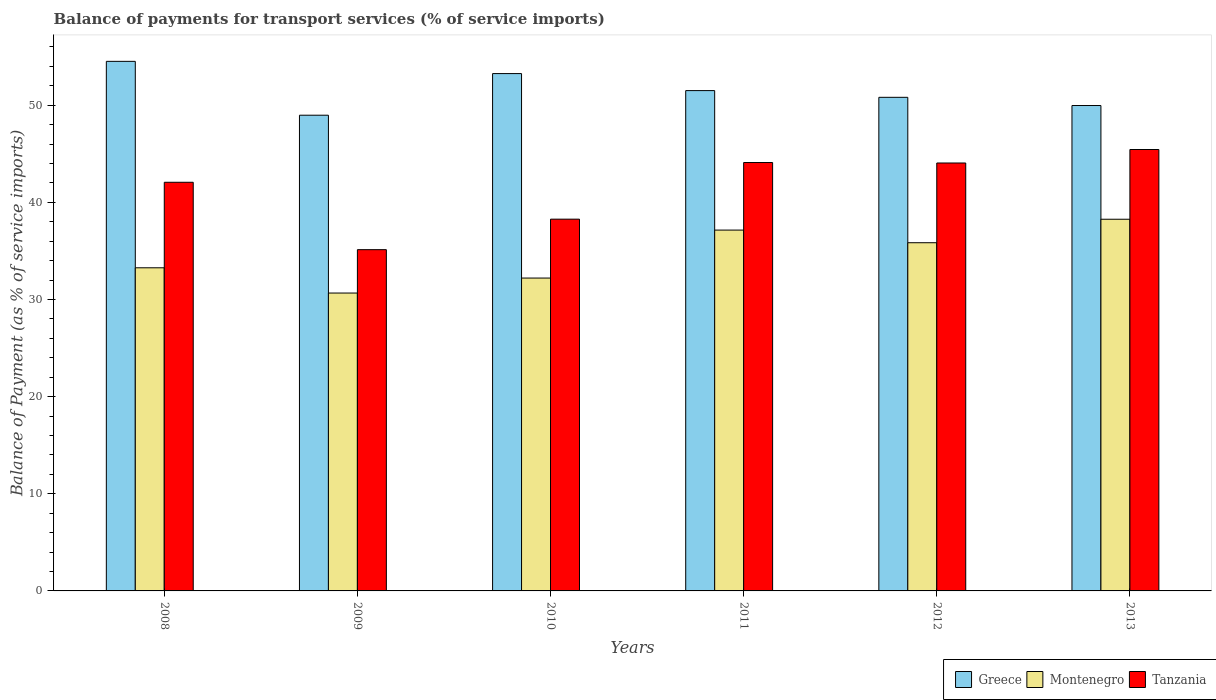How many different coloured bars are there?
Your response must be concise. 3. Are the number of bars per tick equal to the number of legend labels?
Provide a succinct answer. Yes. How many bars are there on the 4th tick from the left?
Offer a terse response. 3. What is the label of the 6th group of bars from the left?
Provide a succinct answer. 2013. What is the balance of payments for transport services in Montenegro in 2011?
Give a very brief answer. 37.14. Across all years, what is the maximum balance of payments for transport services in Montenegro?
Your response must be concise. 38.26. Across all years, what is the minimum balance of payments for transport services in Greece?
Provide a succinct answer. 48.97. In which year was the balance of payments for transport services in Montenegro maximum?
Give a very brief answer. 2013. What is the total balance of payments for transport services in Greece in the graph?
Keep it short and to the point. 309. What is the difference between the balance of payments for transport services in Tanzania in 2009 and that in 2013?
Your answer should be compact. -10.31. What is the difference between the balance of payments for transport services in Greece in 2008 and the balance of payments for transport services in Montenegro in 2010?
Your answer should be compact. 22.31. What is the average balance of payments for transport services in Tanzania per year?
Keep it short and to the point. 41.51. In the year 2011, what is the difference between the balance of payments for transport services in Montenegro and balance of payments for transport services in Tanzania?
Provide a short and direct response. -6.96. What is the ratio of the balance of payments for transport services in Greece in 2011 to that in 2012?
Keep it short and to the point. 1.01. Is the balance of payments for transport services in Montenegro in 2008 less than that in 2013?
Your answer should be very brief. Yes. What is the difference between the highest and the second highest balance of payments for transport services in Greece?
Make the answer very short. 1.26. What is the difference between the highest and the lowest balance of payments for transport services in Tanzania?
Your answer should be compact. 10.31. Is the sum of the balance of payments for transport services in Tanzania in 2008 and 2010 greater than the maximum balance of payments for transport services in Greece across all years?
Offer a terse response. Yes. What does the 2nd bar from the right in 2010 represents?
Keep it short and to the point. Montenegro. Is it the case that in every year, the sum of the balance of payments for transport services in Tanzania and balance of payments for transport services in Greece is greater than the balance of payments for transport services in Montenegro?
Your answer should be compact. Yes. Are all the bars in the graph horizontal?
Provide a succinct answer. No. Are the values on the major ticks of Y-axis written in scientific E-notation?
Ensure brevity in your answer.  No. Does the graph contain any zero values?
Your answer should be very brief. No. Where does the legend appear in the graph?
Offer a terse response. Bottom right. How are the legend labels stacked?
Ensure brevity in your answer.  Horizontal. What is the title of the graph?
Provide a succinct answer. Balance of payments for transport services (% of service imports). What is the label or title of the Y-axis?
Your answer should be compact. Balance of Payment (as % of service imports). What is the Balance of Payment (as % of service imports) of Greece in 2008?
Ensure brevity in your answer.  54.51. What is the Balance of Payment (as % of service imports) of Montenegro in 2008?
Ensure brevity in your answer.  33.26. What is the Balance of Payment (as % of service imports) in Tanzania in 2008?
Offer a terse response. 42.06. What is the Balance of Payment (as % of service imports) in Greece in 2009?
Offer a terse response. 48.97. What is the Balance of Payment (as % of service imports) in Montenegro in 2009?
Give a very brief answer. 30.66. What is the Balance of Payment (as % of service imports) of Tanzania in 2009?
Make the answer very short. 35.13. What is the Balance of Payment (as % of service imports) of Greece in 2010?
Give a very brief answer. 53.25. What is the Balance of Payment (as % of service imports) in Montenegro in 2010?
Your answer should be compact. 32.2. What is the Balance of Payment (as % of service imports) in Tanzania in 2010?
Make the answer very short. 38.27. What is the Balance of Payment (as % of service imports) of Greece in 2011?
Ensure brevity in your answer.  51.5. What is the Balance of Payment (as % of service imports) in Montenegro in 2011?
Offer a terse response. 37.14. What is the Balance of Payment (as % of service imports) of Tanzania in 2011?
Offer a terse response. 44.1. What is the Balance of Payment (as % of service imports) of Greece in 2012?
Provide a succinct answer. 50.81. What is the Balance of Payment (as % of service imports) of Montenegro in 2012?
Ensure brevity in your answer.  35.84. What is the Balance of Payment (as % of service imports) of Tanzania in 2012?
Offer a terse response. 44.05. What is the Balance of Payment (as % of service imports) of Greece in 2013?
Your answer should be compact. 49.96. What is the Balance of Payment (as % of service imports) in Montenegro in 2013?
Offer a very short reply. 38.26. What is the Balance of Payment (as % of service imports) in Tanzania in 2013?
Offer a very short reply. 45.44. Across all years, what is the maximum Balance of Payment (as % of service imports) of Greece?
Make the answer very short. 54.51. Across all years, what is the maximum Balance of Payment (as % of service imports) in Montenegro?
Your answer should be very brief. 38.26. Across all years, what is the maximum Balance of Payment (as % of service imports) of Tanzania?
Your answer should be very brief. 45.44. Across all years, what is the minimum Balance of Payment (as % of service imports) in Greece?
Your answer should be very brief. 48.97. Across all years, what is the minimum Balance of Payment (as % of service imports) in Montenegro?
Offer a terse response. 30.66. Across all years, what is the minimum Balance of Payment (as % of service imports) in Tanzania?
Your response must be concise. 35.13. What is the total Balance of Payment (as % of service imports) of Greece in the graph?
Make the answer very short. 309. What is the total Balance of Payment (as % of service imports) in Montenegro in the graph?
Give a very brief answer. 207.37. What is the total Balance of Payment (as % of service imports) in Tanzania in the graph?
Your answer should be compact. 249.04. What is the difference between the Balance of Payment (as % of service imports) in Greece in 2008 and that in 2009?
Offer a terse response. 5.54. What is the difference between the Balance of Payment (as % of service imports) of Montenegro in 2008 and that in 2009?
Provide a short and direct response. 2.6. What is the difference between the Balance of Payment (as % of service imports) in Tanzania in 2008 and that in 2009?
Ensure brevity in your answer.  6.94. What is the difference between the Balance of Payment (as % of service imports) in Greece in 2008 and that in 2010?
Your response must be concise. 1.26. What is the difference between the Balance of Payment (as % of service imports) of Montenegro in 2008 and that in 2010?
Provide a succinct answer. 1.06. What is the difference between the Balance of Payment (as % of service imports) of Tanzania in 2008 and that in 2010?
Provide a short and direct response. 3.8. What is the difference between the Balance of Payment (as % of service imports) in Greece in 2008 and that in 2011?
Your answer should be compact. 3.01. What is the difference between the Balance of Payment (as % of service imports) in Montenegro in 2008 and that in 2011?
Keep it short and to the point. -3.88. What is the difference between the Balance of Payment (as % of service imports) of Tanzania in 2008 and that in 2011?
Give a very brief answer. -2.03. What is the difference between the Balance of Payment (as % of service imports) in Greece in 2008 and that in 2012?
Provide a short and direct response. 3.7. What is the difference between the Balance of Payment (as % of service imports) in Montenegro in 2008 and that in 2012?
Your response must be concise. -2.58. What is the difference between the Balance of Payment (as % of service imports) of Tanzania in 2008 and that in 2012?
Offer a terse response. -1.98. What is the difference between the Balance of Payment (as % of service imports) in Greece in 2008 and that in 2013?
Provide a short and direct response. 4.55. What is the difference between the Balance of Payment (as % of service imports) in Montenegro in 2008 and that in 2013?
Offer a very short reply. -5. What is the difference between the Balance of Payment (as % of service imports) of Tanzania in 2008 and that in 2013?
Offer a very short reply. -3.37. What is the difference between the Balance of Payment (as % of service imports) of Greece in 2009 and that in 2010?
Provide a short and direct response. -4.28. What is the difference between the Balance of Payment (as % of service imports) of Montenegro in 2009 and that in 2010?
Your answer should be very brief. -1.54. What is the difference between the Balance of Payment (as % of service imports) of Tanzania in 2009 and that in 2010?
Provide a short and direct response. -3.14. What is the difference between the Balance of Payment (as % of service imports) of Greece in 2009 and that in 2011?
Provide a succinct answer. -2.53. What is the difference between the Balance of Payment (as % of service imports) in Montenegro in 2009 and that in 2011?
Offer a terse response. -6.48. What is the difference between the Balance of Payment (as % of service imports) of Tanzania in 2009 and that in 2011?
Provide a short and direct response. -8.97. What is the difference between the Balance of Payment (as % of service imports) in Greece in 2009 and that in 2012?
Offer a very short reply. -1.84. What is the difference between the Balance of Payment (as % of service imports) of Montenegro in 2009 and that in 2012?
Ensure brevity in your answer.  -5.18. What is the difference between the Balance of Payment (as % of service imports) of Tanzania in 2009 and that in 2012?
Your answer should be very brief. -8.92. What is the difference between the Balance of Payment (as % of service imports) of Greece in 2009 and that in 2013?
Your response must be concise. -1. What is the difference between the Balance of Payment (as % of service imports) in Montenegro in 2009 and that in 2013?
Ensure brevity in your answer.  -7.6. What is the difference between the Balance of Payment (as % of service imports) of Tanzania in 2009 and that in 2013?
Provide a succinct answer. -10.31. What is the difference between the Balance of Payment (as % of service imports) of Greece in 2010 and that in 2011?
Give a very brief answer. 1.75. What is the difference between the Balance of Payment (as % of service imports) in Montenegro in 2010 and that in 2011?
Your answer should be very brief. -4.94. What is the difference between the Balance of Payment (as % of service imports) of Tanzania in 2010 and that in 2011?
Give a very brief answer. -5.83. What is the difference between the Balance of Payment (as % of service imports) in Greece in 2010 and that in 2012?
Offer a very short reply. 2.44. What is the difference between the Balance of Payment (as % of service imports) of Montenegro in 2010 and that in 2012?
Provide a short and direct response. -3.64. What is the difference between the Balance of Payment (as % of service imports) in Tanzania in 2010 and that in 2012?
Offer a very short reply. -5.78. What is the difference between the Balance of Payment (as % of service imports) in Greece in 2010 and that in 2013?
Keep it short and to the point. 3.29. What is the difference between the Balance of Payment (as % of service imports) of Montenegro in 2010 and that in 2013?
Offer a terse response. -6.06. What is the difference between the Balance of Payment (as % of service imports) in Tanzania in 2010 and that in 2013?
Ensure brevity in your answer.  -7.17. What is the difference between the Balance of Payment (as % of service imports) in Greece in 2011 and that in 2012?
Provide a short and direct response. 0.69. What is the difference between the Balance of Payment (as % of service imports) of Montenegro in 2011 and that in 2012?
Offer a very short reply. 1.3. What is the difference between the Balance of Payment (as % of service imports) of Tanzania in 2011 and that in 2012?
Your answer should be compact. 0.05. What is the difference between the Balance of Payment (as % of service imports) in Greece in 2011 and that in 2013?
Offer a terse response. 1.54. What is the difference between the Balance of Payment (as % of service imports) in Montenegro in 2011 and that in 2013?
Offer a terse response. -1.12. What is the difference between the Balance of Payment (as % of service imports) of Tanzania in 2011 and that in 2013?
Your answer should be very brief. -1.34. What is the difference between the Balance of Payment (as % of service imports) of Greece in 2012 and that in 2013?
Offer a terse response. 0.85. What is the difference between the Balance of Payment (as % of service imports) in Montenegro in 2012 and that in 2013?
Provide a short and direct response. -2.42. What is the difference between the Balance of Payment (as % of service imports) in Tanzania in 2012 and that in 2013?
Keep it short and to the point. -1.39. What is the difference between the Balance of Payment (as % of service imports) in Greece in 2008 and the Balance of Payment (as % of service imports) in Montenegro in 2009?
Your answer should be very brief. 23.85. What is the difference between the Balance of Payment (as % of service imports) of Greece in 2008 and the Balance of Payment (as % of service imports) of Tanzania in 2009?
Provide a succinct answer. 19.38. What is the difference between the Balance of Payment (as % of service imports) in Montenegro in 2008 and the Balance of Payment (as % of service imports) in Tanzania in 2009?
Keep it short and to the point. -1.86. What is the difference between the Balance of Payment (as % of service imports) of Greece in 2008 and the Balance of Payment (as % of service imports) of Montenegro in 2010?
Provide a succinct answer. 22.31. What is the difference between the Balance of Payment (as % of service imports) in Greece in 2008 and the Balance of Payment (as % of service imports) in Tanzania in 2010?
Your answer should be compact. 16.24. What is the difference between the Balance of Payment (as % of service imports) in Montenegro in 2008 and the Balance of Payment (as % of service imports) in Tanzania in 2010?
Provide a succinct answer. -5. What is the difference between the Balance of Payment (as % of service imports) of Greece in 2008 and the Balance of Payment (as % of service imports) of Montenegro in 2011?
Ensure brevity in your answer.  17.37. What is the difference between the Balance of Payment (as % of service imports) in Greece in 2008 and the Balance of Payment (as % of service imports) in Tanzania in 2011?
Make the answer very short. 10.41. What is the difference between the Balance of Payment (as % of service imports) of Montenegro in 2008 and the Balance of Payment (as % of service imports) of Tanzania in 2011?
Provide a succinct answer. -10.84. What is the difference between the Balance of Payment (as % of service imports) in Greece in 2008 and the Balance of Payment (as % of service imports) in Montenegro in 2012?
Provide a succinct answer. 18.67. What is the difference between the Balance of Payment (as % of service imports) in Greece in 2008 and the Balance of Payment (as % of service imports) in Tanzania in 2012?
Provide a short and direct response. 10.46. What is the difference between the Balance of Payment (as % of service imports) in Montenegro in 2008 and the Balance of Payment (as % of service imports) in Tanzania in 2012?
Offer a very short reply. -10.79. What is the difference between the Balance of Payment (as % of service imports) in Greece in 2008 and the Balance of Payment (as % of service imports) in Montenegro in 2013?
Provide a succinct answer. 16.25. What is the difference between the Balance of Payment (as % of service imports) of Greece in 2008 and the Balance of Payment (as % of service imports) of Tanzania in 2013?
Give a very brief answer. 9.07. What is the difference between the Balance of Payment (as % of service imports) of Montenegro in 2008 and the Balance of Payment (as % of service imports) of Tanzania in 2013?
Keep it short and to the point. -12.18. What is the difference between the Balance of Payment (as % of service imports) of Greece in 2009 and the Balance of Payment (as % of service imports) of Montenegro in 2010?
Your answer should be very brief. 16.76. What is the difference between the Balance of Payment (as % of service imports) in Montenegro in 2009 and the Balance of Payment (as % of service imports) in Tanzania in 2010?
Make the answer very short. -7.6. What is the difference between the Balance of Payment (as % of service imports) of Greece in 2009 and the Balance of Payment (as % of service imports) of Montenegro in 2011?
Provide a short and direct response. 11.82. What is the difference between the Balance of Payment (as % of service imports) of Greece in 2009 and the Balance of Payment (as % of service imports) of Tanzania in 2011?
Make the answer very short. 4.87. What is the difference between the Balance of Payment (as % of service imports) in Montenegro in 2009 and the Balance of Payment (as % of service imports) in Tanzania in 2011?
Provide a succinct answer. -13.44. What is the difference between the Balance of Payment (as % of service imports) of Greece in 2009 and the Balance of Payment (as % of service imports) of Montenegro in 2012?
Your answer should be very brief. 13.13. What is the difference between the Balance of Payment (as % of service imports) of Greece in 2009 and the Balance of Payment (as % of service imports) of Tanzania in 2012?
Give a very brief answer. 4.92. What is the difference between the Balance of Payment (as % of service imports) of Montenegro in 2009 and the Balance of Payment (as % of service imports) of Tanzania in 2012?
Ensure brevity in your answer.  -13.39. What is the difference between the Balance of Payment (as % of service imports) in Greece in 2009 and the Balance of Payment (as % of service imports) in Montenegro in 2013?
Make the answer very short. 10.71. What is the difference between the Balance of Payment (as % of service imports) in Greece in 2009 and the Balance of Payment (as % of service imports) in Tanzania in 2013?
Your answer should be compact. 3.53. What is the difference between the Balance of Payment (as % of service imports) in Montenegro in 2009 and the Balance of Payment (as % of service imports) in Tanzania in 2013?
Offer a very short reply. -14.78. What is the difference between the Balance of Payment (as % of service imports) in Greece in 2010 and the Balance of Payment (as % of service imports) in Montenegro in 2011?
Make the answer very short. 16.11. What is the difference between the Balance of Payment (as % of service imports) of Greece in 2010 and the Balance of Payment (as % of service imports) of Tanzania in 2011?
Your response must be concise. 9.15. What is the difference between the Balance of Payment (as % of service imports) of Montenegro in 2010 and the Balance of Payment (as % of service imports) of Tanzania in 2011?
Offer a terse response. -11.89. What is the difference between the Balance of Payment (as % of service imports) in Greece in 2010 and the Balance of Payment (as % of service imports) in Montenegro in 2012?
Your response must be concise. 17.41. What is the difference between the Balance of Payment (as % of service imports) in Greece in 2010 and the Balance of Payment (as % of service imports) in Tanzania in 2012?
Offer a terse response. 9.2. What is the difference between the Balance of Payment (as % of service imports) of Montenegro in 2010 and the Balance of Payment (as % of service imports) of Tanzania in 2012?
Your answer should be very brief. -11.84. What is the difference between the Balance of Payment (as % of service imports) of Greece in 2010 and the Balance of Payment (as % of service imports) of Montenegro in 2013?
Provide a succinct answer. 14.99. What is the difference between the Balance of Payment (as % of service imports) in Greece in 2010 and the Balance of Payment (as % of service imports) in Tanzania in 2013?
Make the answer very short. 7.81. What is the difference between the Balance of Payment (as % of service imports) of Montenegro in 2010 and the Balance of Payment (as % of service imports) of Tanzania in 2013?
Give a very brief answer. -13.23. What is the difference between the Balance of Payment (as % of service imports) of Greece in 2011 and the Balance of Payment (as % of service imports) of Montenegro in 2012?
Your response must be concise. 15.66. What is the difference between the Balance of Payment (as % of service imports) in Greece in 2011 and the Balance of Payment (as % of service imports) in Tanzania in 2012?
Offer a very short reply. 7.45. What is the difference between the Balance of Payment (as % of service imports) of Montenegro in 2011 and the Balance of Payment (as % of service imports) of Tanzania in 2012?
Provide a short and direct response. -6.91. What is the difference between the Balance of Payment (as % of service imports) of Greece in 2011 and the Balance of Payment (as % of service imports) of Montenegro in 2013?
Keep it short and to the point. 13.24. What is the difference between the Balance of Payment (as % of service imports) of Greece in 2011 and the Balance of Payment (as % of service imports) of Tanzania in 2013?
Provide a short and direct response. 6.06. What is the difference between the Balance of Payment (as % of service imports) in Montenegro in 2011 and the Balance of Payment (as % of service imports) in Tanzania in 2013?
Offer a very short reply. -8.29. What is the difference between the Balance of Payment (as % of service imports) of Greece in 2012 and the Balance of Payment (as % of service imports) of Montenegro in 2013?
Keep it short and to the point. 12.55. What is the difference between the Balance of Payment (as % of service imports) of Greece in 2012 and the Balance of Payment (as % of service imports) of Tanzania in 2013?
Provide a succinct answer. 5.37. What is the difference between the Balance of Payment (as % of service imports) of Montenegro in 2012 and the Balance of Payment (as % of service imports) of Tanzania in 2013?
Offer a terse response. -9.6. What is the average Balance of Payment (as % of service imports) of Greece per year?
Provide a succinct answer. 51.5. What is the average Balance of Payment (as % of service imports) in Montenegro per year?
Give a very brief answer. 34.56. What is the average Balance of Payment (as % of service imports) of Tanzania per year?
Keep it short and to the point. 41.51. In the year 2008, what is the difference between the Balance of Payment (as % of service imports) in Greece and Balance of Payment (as % of service imports) in Montenegro?
Offer a very short reply. 21.25. In the year 2008, what is the difference between the Balance of Payment (as % of service imports) of Greece and Balance of Payment (as % of service imports) of Tanzania?
Make the answer very short. 12.45. In the year 2008, what is the difference between the Balance of Payment (as % of service imports) of Montenegro and Balance of Payment (as % of service imports) of Tanzania?
Give a very brief answer. -8.8. In the year 2009, what is the difference between the Balance of Payment (as % of service imports) in Greece and Balance of Payment (as % of service imports) in Montenegro?
Provide a succinct answer. 18.3. In the year 2009, what is the difference between the Balance of Payment (as % of service imports) of Greece and Balance of Payment (as % of service imports) of Tanzania?
Ensure brevity in your answer.  13.84. In the year 2009, what is the difference between the Balance of Payment (as % of service imports) of Montenegro and Balance of Payment (as % of service imports) of Tanzania?
Give a very brief answer. -4.46. In the year 2010, what is the difference between the Balance of Payment (as % of service imports) of Greece and Balance of Payment (as % of service imports) of Montenegro?
Your answer should be very brief. 21.05. In the year 2010, what is the difference between the Balance of Payment (as % of service imports) of Greece and Balance of Payment (as % of service imports) of Tanzania?
Your answer should be very brief. 14.98. In the year 2010, what is the difference between the Balance of Payment (as % of service imports) in Montenegro and Balance of Payment (as % of service imports) in Tanzania?
Give a very brief answer. -6.06. In the year 2011, what is the difference between the Balance of Payment (as % of service imports) of Greece and Balance of Payment (as % of service imports) of Montenegro?
Offer a terse response. 14.36. In the year 2011, what is the difference between the Balance of Payment (as % of service imports) in Greece and Balance of Payment (as % of service imports) in Tanzania?
Keep it short and to the point. 7.4. In the year 2011, what is the difference between the Balance of Payment (as % of service imports) in Montenegro and Balance of Payment (as % of service imports) in Tanzania?
Make the answer very short. -6.96. In the year 2012, what is the difference between the Balance of Payment (as % of service imports) in Greece and Balance of Payment (as % of service imports) in Montenegro?
Your answer should be compact. 14.97. In the year 2012, what is the difference between the Balance of Payment (as % of service imports) of Greece and Balance of Payment (as % of service imports) of Tanzania?
Your answer should be compact. 6.76. In the year 2012, what is the difference between the Balance of Payment (as % of service imports) of Montenegro and Balance of Payment (as % of service imports) of Tanzania?
Make the answer very short. -8.21. In the year 2013, what is the difference between the Balance of Payment (as % of service imports) in Greece and Balance of Payment (as % of service imports) in Montenegro?
Provide a short and direct response. 11.7. In the year 2013, what is the difference between the Balance of Payment (as % of service imports) of Greece and Balance of Payment (as % of service imports) of Tanzania?
Your answer should be very brief. 4.53. In the year 2013, what is the difference between the Balance of Payment (as % of service imports) of Montenegro and Balance of Payment (as % of service imports) of Tanzania?
Provide a short and direct response. -7.18. What is the ratio of the Balance of Payment (as % of service imports) in Greece in 2008 to that in 2009?
Your answer should be compact. 1.11. What is the ratio of the Balance of Payment (as % of service imports) in Montenegro in 2008 to that in 2009?
Make the answer very short. 1.08. What is the ratio of the Balance of Payment (as % of service imports) of Tanzania in 2008 to that in 2009?
Provide a succinct answer. 1.2. What is the ratio of the Balance of Payment (as % of service imports) in Greece in 2008 to that in 2010?
Your response must be concise. 1.02. What is the ratio of the Balance of Payment (as % of service imports) in Montenegro in 2008 to that in 2010?
Ensure brevity in your answer.  1.03. What is the ratio of the Balance of Payment (as % of service imports) in Tanzania in 2008 to that in 2010?
Provide a short and direct response. 1.1. What is the ratio of the Balance of Payment (as % of service imports) in Greece in 2008 to that in 2011?
Your answer should be very brief. 1.06. What is the ratio of the Balance of Payment (as % of service imports) of Montenegro in 2008 to that in 2011?
Offer a terse response. 0.9. What is the ratio of the Balance of Payment (as % of service imports) of Tanzania in 2008 to that in 2011?
Your answer should be very brief. 0.95. What is the ratio of the Balance of Payment (as % of service imports) of Greece in 2008 to that in 2012?
Offer a very short reply. 1.07. What is the ratio of the Balance of Payment (as % of service imports) in Montenegro in 2008 to that in 2012?
Your response must be concise. 0.93. What is the ratio of the Balance of Payment (as % of service imports) in Tanzania in 2008 to that in 2012?
Your response must be concise. 0.95. What is the ratio of the Balance of Payment (as % of service imports) of Greece in 2008 to that in 2013?
Provide a succinct answer. 1.09. What is the ratio of the Balance of Payment (as % of service imports) in Montenegro in 2008 to that in 2013?
Your answer should be very brief. 0.87. What is the ratio of the Balance of Payment (as % of service imports) of Tanzania in 2008 to that in 2013?
Make the answer very short. 0.93. What is the ratio of the Balance of Payment (as % of service imports) of Greece in 2009 to that in 2010?
Make the answer very short. 0.92. What is the ratio of the Balance of Payment (as % of service imports) in Montenegro in 2009 to that in 2010?
Offer a terse response. 0.95. What is the ratio of the Balance of Payment (as % of service imports) of Tanzania in 2009 to that in 2010?
Give a very brief answer. 0.92. What is the ratio of the Balance of Payment (as % of service imports) in Greece in 2009 to that in 2011?
Ensure brevity in your answer.  0.95. What is the ratio of the Balance of Payment (as % of service imports) of Montenegro in 2009 to that in 2011?
Provide a short and direct response. 0.83. What is the ratio of the Balance of Payment (as % of service imports) in Tanzania in 2009 to that in 2011?
Give a very brief answer. 0.8. What is the ratio of the Balance of Payment (as % of service imports) in Greece in 2009 to that in 2012?
Make the answer very short. 0.96. What is the ratio of the Balance of Payment (as % of service imports) in Montenegro in 2009 to that in 2012?
Ensure brevity in your answer.  0.86. What is the ratio of the Balance of Payment (as % of service imports) in Tanzania in 2009 to that in 2012?
Offer a very short reply. 0.8. What is the ratio of the Balance of Payment (as % of service imports) in Montenegro in 2009 to that in 2013?
Provide a short and direct response. 0.8. What is the ratio of the Balance of Payment (as % of service imports) in Tanzania in 2009 to that in 2013?
Your answer should be compact. 0.77. What is the ratio of the Balance of Payment (as % of service imports) of Greece in 2010 to that in 2011?
Your answer should be very brief. 1.03. What is the ratio of the Balance of Payment (as % of service imports) of Montenegro in 2010 to that in 2011?
Offer a very short reply. 0.87. What is the ratio of the Balance of Payment (as % of service imports) of Tanzania in 2010 to that in 2011?
Give a very brief answer. 0.87. What is the ratio of the Balance of Payment (as % of service imports) in Greece in 2010 to that in 2012?
Offer a very short reply. 1.05. What is the ratio of the Balance of Payment (as % of service imports) in Montenegro in 2010 to that in 2012?
Offer a very short reply. 0.9. What is the ratio of the Balance of Payment (as % of service imports) of Tanzania in 2010 to that in 2012?
Make the answer very short. 0.87. What is the ratio of the Balance of Payment (as % of service imports) of Greece in 2010 to that in 2013?
Your response must be concise. 1.07. What is the ratio of the Balance of Payment (as % of service imports) of Montenegro in 2010 to that in 2013?
Give a very brief answer. 0.84. What is the ratio of the Balance of Payment (as % of service imports) of Tanzania in 2010 to that in 2013?
Your answer should be very brief. 0.84. What is the ratio of the Balance of Payment (as % of service imports) of Greece in 2011 to that in 2012?
Offer a very short reply. 1.01. What is the ratio of the Balance of Payment (as % of service imports) of Montenegro in 2011 to that in 2012?
Provide a short and direct response. 1.04. What is the ratio of the Balance of Payment (as % of service imports) of Greece in 2011 to that in 2013?
Keep it short and to the point. 1.03. What is the ratio of the Balance of Payment (as % of service imports) of Montenegro in 2011 to that in 2013?
Keep it short and to the point. 0.97. What is the ratio of the Balance of Payment (as % of service imports) of Tanzania in 2011 to that in 2013?
Provide a short and direct response. 0.97. What is the ratio of the Balance of Payment (as % of service imports) of Greece in 2012 to that in 2013?
Make the answer very short. 1.02. What is the ratio of the Balance of Payment (as % of service imports) of Montenegro in 2012 to that in 2013?
Offer a very short reply. 0.94. What is the ratio of the Balance of Payment (as % of service imports) of Tanzania in 2012 to that in 2013?
Offer a very short reply. 0.97. What is the difference between the highest and the second highest Balance of Payment (as % of service imports) in Greece?
Make the answer very short. 1.26. What is the difference between the highest and the second highest Balance of Payment (as % of service imports) in Montenegro?
Your answer should be compact. 1.12. What is the difference between the highest and the second highest Balance of Payment (as % of service imports) in Tanzania?
Give a very brief answer. 1.34. What is the difference between the highest and the lowest Balance of Payment (as % of service imports) of Greece?
Give a very brief answer. 5.54. What is the difference between the highest and the lowest Balance of Payment (as % of service imports) of Montenegro?
Offer a terse response. 7.6. What is the difference between the highest and the lowest Balance of Payment (as % of service imports) in Tanzania?
Ensure brevity in your answer.  10.31. 